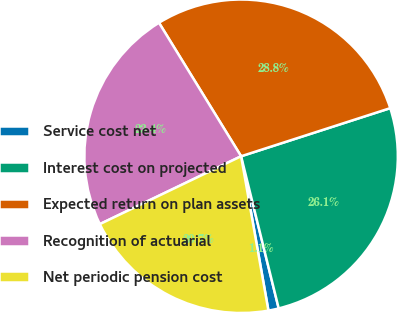<chart> <loc_0><loc_0><loc_500><loc_500><pie_chart><fcel>Service cost net<fcel>Interest cost on projected<fcel>Expected return on plan assets<fcel>Recognition of actuarial<fcel>Net periodic pension cost<nl><fcel>1.07%<fcel>26.11%<fcel>28.81%<fcel>23.35%<fcel>20.66%<nl></chart> 